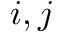Convert formula to latex. <formula><loc_0><loc_0><loc_500><loc_500>i , j</formula> 